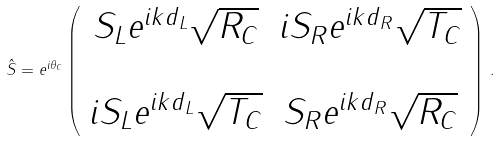<formula> <loc_0><loc_0><loc_500><loc_500>\hat { S } = e ^ { i \theta _ { C } } \left ( \begin{array} { c c } S _ { L } e ^ { i k d _ { L } } \sqrt { R _ { C } } & i S _ { R } e ^ { i k d _ { R } } \sqrt { T _ { C } } \\ \ \\ i S _ { L } e ^ { i k d _ { L } } \sqrt { T _ { C } } & S _ { R } e ^ { i k d _ { R } } \sqrt { R _ { C } } \end{array} \right ) \, .</formula> 